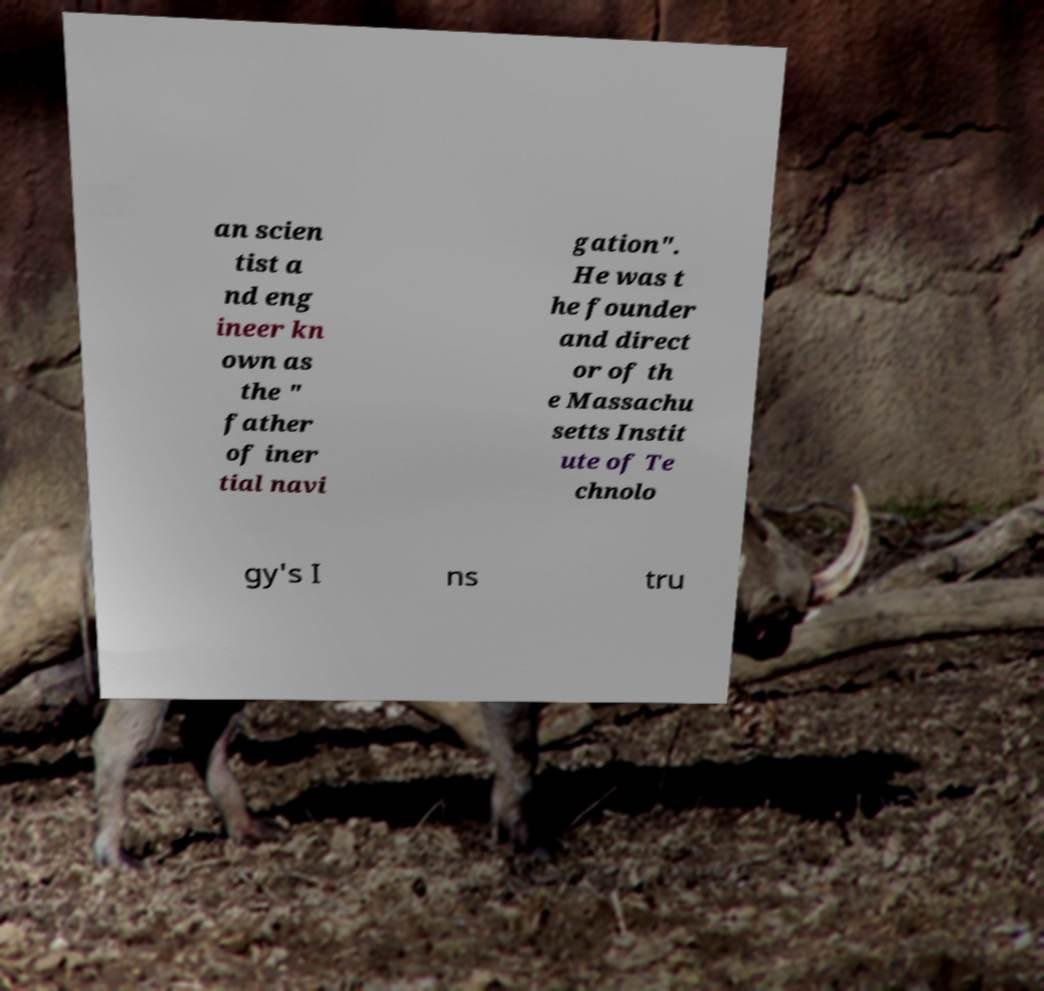Can you accurately transcribe the text from the provided image for me? an scien tist a nd eng ineer kn own as the " father of iner tial navi gation". He was t he founder and direct or of th e Massachu setts Instit ute of Te chnolo gy's I ns tru 